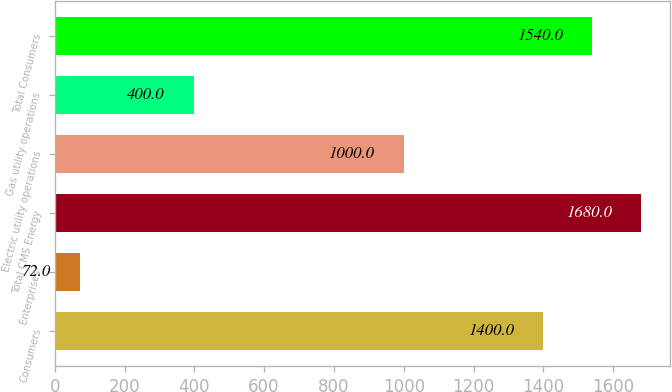Convert chart to OTSL. <chart><loc_0><loc_0><loc_500><loc_500><bar_chart><fcel>Consumers<fcel>Enterprises<fcel>Total CMS Energy<fcel>Electric utility operations<fcel>Gas utility operations<fcel>Total Consumers<nl><fcel>1400<fcel>72<fcel>1680<fcel>1000<fcel>400<fcel>1540<nl></chart> 